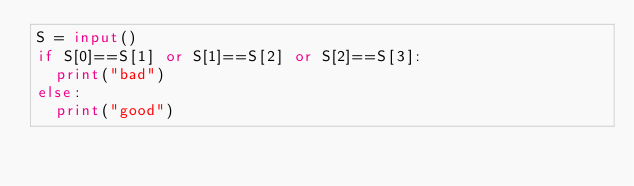<code> <loc_0><loc_0><loc_500><loc_500><_Python_>S = input()
if S[0]==S[1] or S[1]==S[2] or S[2]==S[3]:
  print("bad")
else:
  print("good")
</code> 